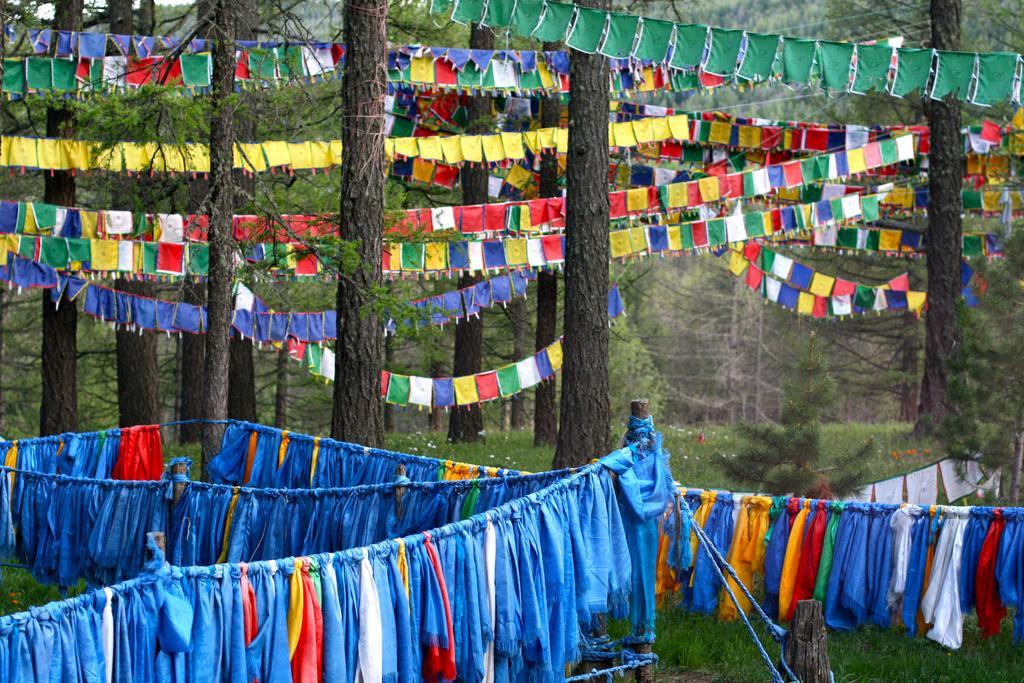How would you summarize this image in a sentence or two? In this image we can see the trees, flags, grass, ropes and also the clothes. 